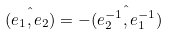Convert formula to latex. <formula><loc_0><loc_0><loc_500><loc_500>\hat { ( { e } _ { 1 } , { e } _ { 2 } ) } = - \hat { ( { e } _ { 2 } ^ { - 1 } , { e } _ { 1 } ^ { - 1 } ) }</formula> 